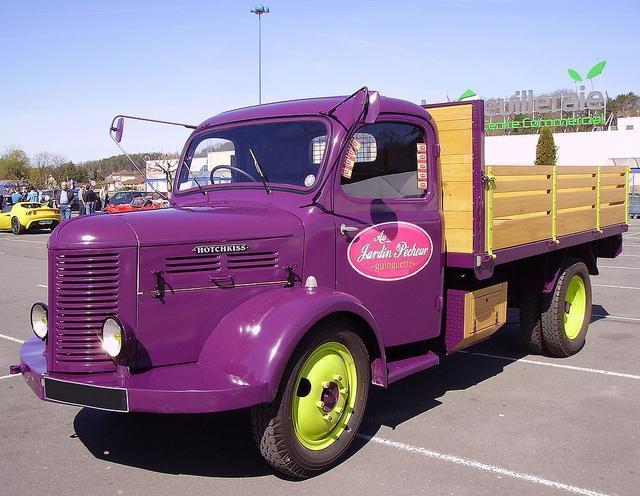Which television character is the same color as this truck?
Pick the right solution, then justify: 'Answer: answer
Rationale: rationale.'
Options: Uncle fester, barney, lamb chop, popeye. Answer: barney.
Rationale: The purple truck and barney are the same color. 